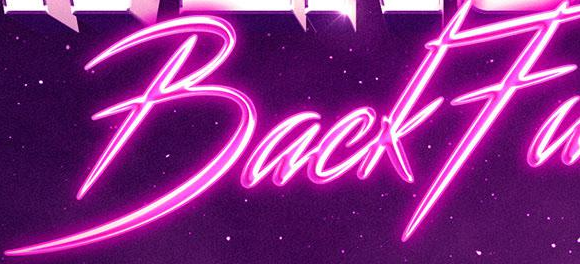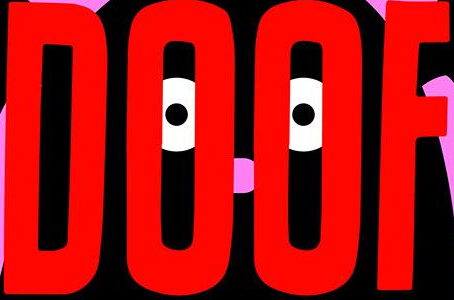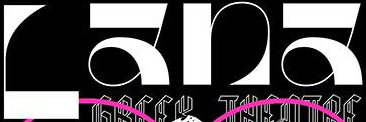Read the text content from these images in order, separated by a semicolon. BackFa; DOOF; Lana 